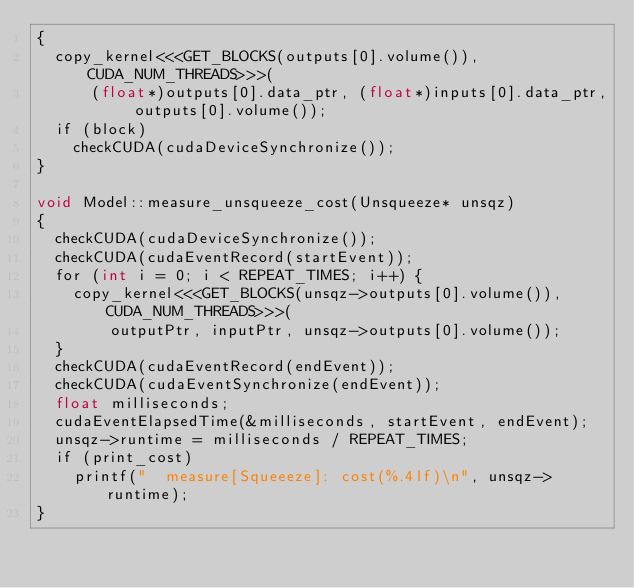<code> <loc_0><loc_0><loc_500><loc_500><_Cuda_>{
  copy_kernel<<<GET_BLOCKS(outputs[0].volume()), CUDA_NUM_THREADS>>>(
      (float*)outputs[0].data_ptr, (float*)inputs[0].data_ptr, outputs[0].volume());
  if (block)
    checkCUDA(cudaDeviceSynchronize());
}

void Model::measure_unsqueeze_cost(Unsqueeze* unsqz)
{
  checkCUDA(cudaDeviceSynchronize());
  checkCUDA(cudaEventRecord(startEvent));
  for (int i = 0; i < REPEAT_TIMES; i++) {
    copy_kernel<<<GET_BLOCKS(unsqz->outputs[0].volume()), CUDA_NUM_THREADS>>>(
        outputPtr, inputPtr, unsqz->outputs[0].volume());
  }
  checkCUDA(cudaEventRecord(endEvent));
  checkCUDA(cudaEventSynchronize(endEvent));
  float milliseconds;
  cudaEventElapsedTime(&milliseconds, startEvent, endEvent);
  unsqz->runtime = milliseconds / REPEAT_TIMES;
  if (print_cost)
    printf("  measure[Squeeeze]: cost(%.4lf)\n", unsqz->runtime);
}
</code> 